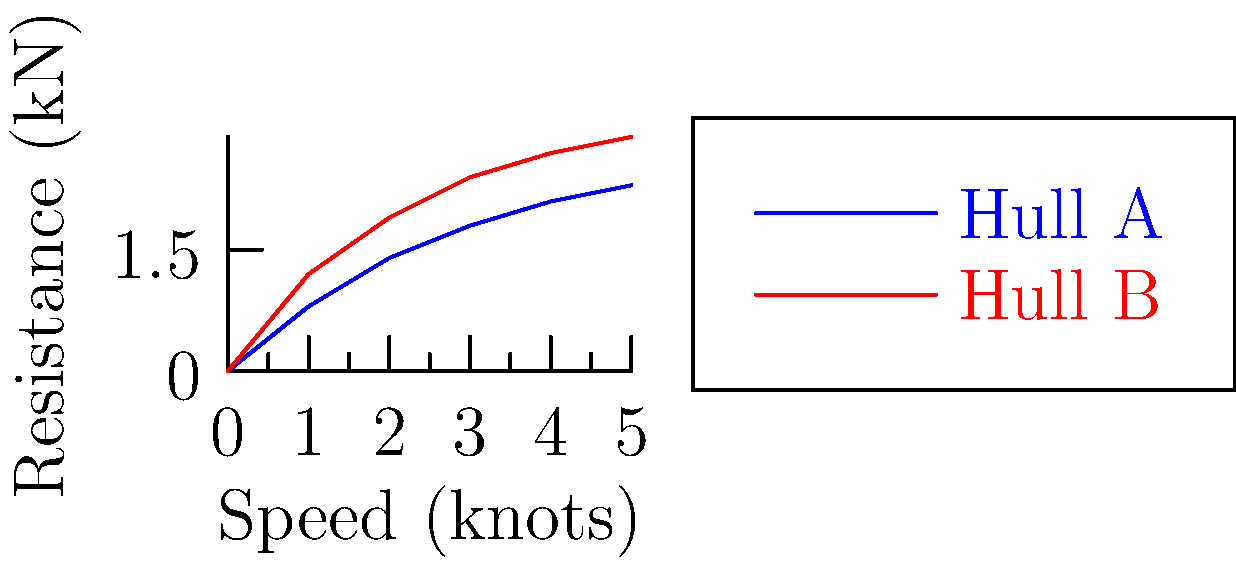During a casual sailing trip, you notice your yacht performing differently than your friend's. Upon investigation, you discover that your hulls have different shapes. The graph shows the hydrodynamic resistance for two hull shapes (A and B) at various speeds. At what speed (in knots) does Hull B experience twice the resistance of Hull A? To solve this problem, we need to follow these steps:

1. Examine the graph to identify where the resistance of Hull B is twice that of Hull A.
2. For each speed value, calculate the ratio of Hull B's resistance to Hull A's resistance.
3. Find the speed where this ratio is closest to 2.

Let's go through the data points:

At 0 knots: Both hulls have 0 resistance, so the ratio is undefined.
At 1 knot: Hull A = 0.8 kN, Hull B = 1.2 kN
Ratio = 1.2 / 0.8 = 1.5

At 2 knots: Hull A = 1.4 kN, Hull B = 1.9 kN
Ratio = 1.9 / 1.4 ≈ 1.36

At 3 knots: Hull A = 1.8 kN, Hull B = 2.4 kN
Ratio = 2.4 / 1.8 = 1.33

At 4 knots: Hull A = 2.1 kN, Hull B = 2.7 kN
Ratio = 2.7 / 2.1 ≈ 1.29

At 5 knots: Hull A = 2.3 kN, Hull B = 2.9 kN
Ratio = 2.9 / 2.3 ≈ 1.26

The ratio is closest to 2 at 1 knot, where Hull B experiences 1.5 times the resistance of Hull A. This is the closest we get to double the resistance within the given data range.
Answer: 1 knot 